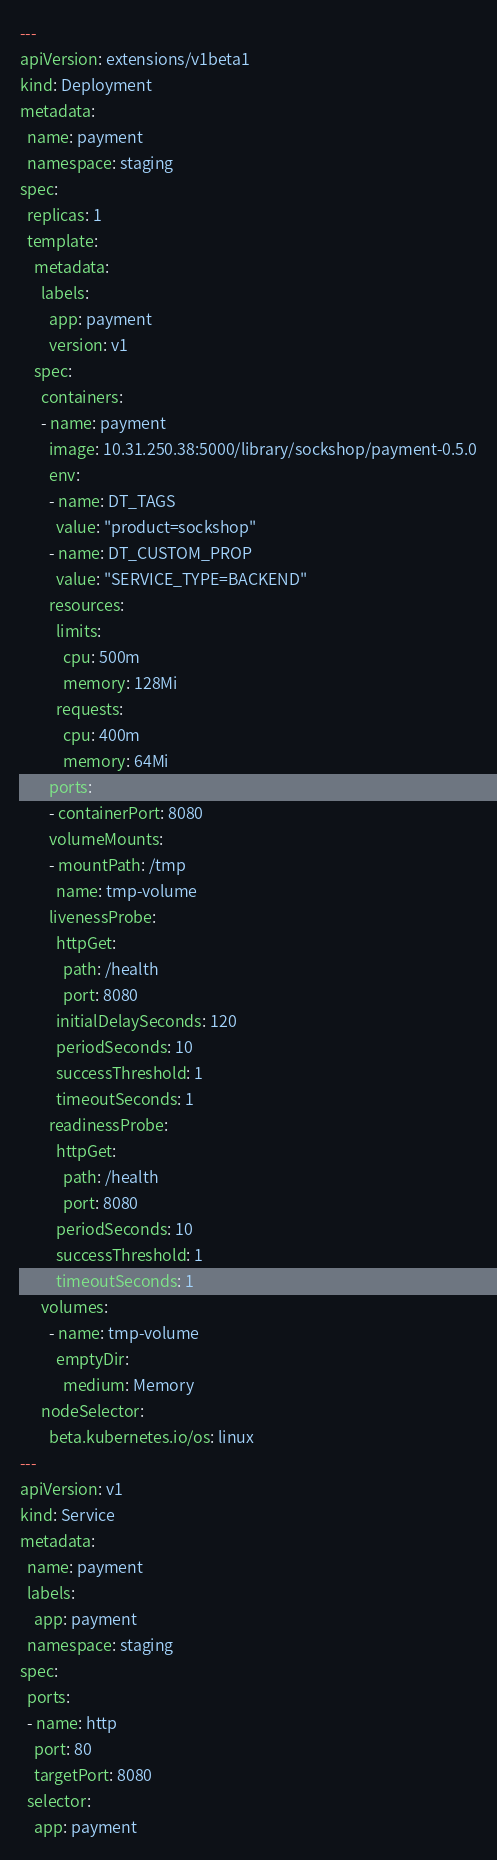<code> <loc_0><loc_0><loc_500><loc_500><_YAML_>---
apiVersion: extensions/v1beta1
kind: Deployment
metadata:
  name: payment
  namespace: staging
spec:
  replicas: 1
  template:
    metadata:
      labels:
        app: payment
        version: v1
    spec:
      containers:
      - name: payment
        image: 10.31.250.38:5000/library/sockshop/payment-0.5.0
        env: 
        - name: DT_TAGS
          value: "product=sockshop"
        - name: DT_CUSTOM_PROP
          value: "SERVICE_TYPE=BACKEND"
        resources:
          limits:
            cpu: 500m
            memory: 128Mi
          requests:
            cpu: 400m
            memory: 64Mi
        ports:
        - containerPort: 8080
        volumeMounts:
        - mountPath: /tmp
          name: tmp-volume
        livenessProbe:
          httpGet:
            path: /health
            port: 8080
          initialDelaySeconds: 120
          periodSeconds: 10
          successThreshold: 1
          timeoutSeconds: 1
        readinessProbe:
          httpGet:
            path: /health
            port: 8080
          periodSeconds: 10
          successThreshold: 1
          timeoutSeconds: 1
      volumes:
        - name: tmp-volume
          emptyDir:
            medium: Memory
      nodeSelector:
        beta.kubernetes.io/os: linux
---
apiVersion: v1
kind: Service
metadata:
  name: payment
  labels:
    app: payment
  namespace: staging
spec:
  ports:
  - name: http
    port: 80
    targetPort: 8080
  selector:
    app: payment
</code> 